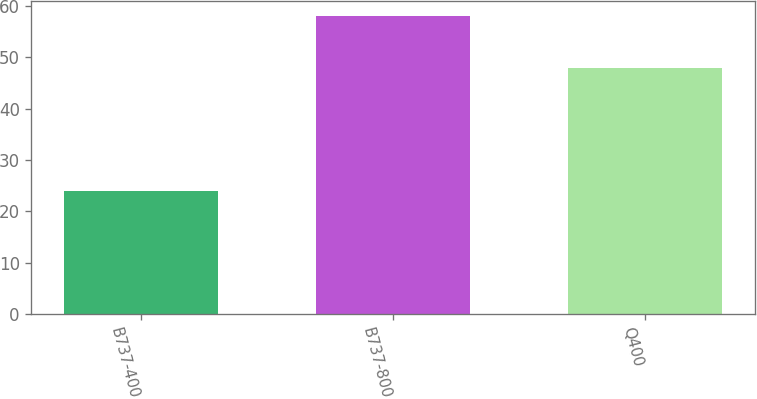Convert chart. <chart><loc_0><loc_0><loc_500><loc_500><bar_chart><fcel>B737-400<fcel>B737-800<fcel>Q400<nl><fcel>24<fcel>58<fcel>48<nl></chart> 